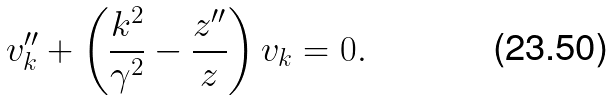<formula> <loc_0><loc_0><loc_500><loc_500>v _ { k } ^ { \prime \prime } + \left ( \frac { k ^ { 2 } } { \gamma ^ { 2 } } - \frac { z ^ { \prime \prime } } { z } \right ) v _ { k } = 0 .</formula> 